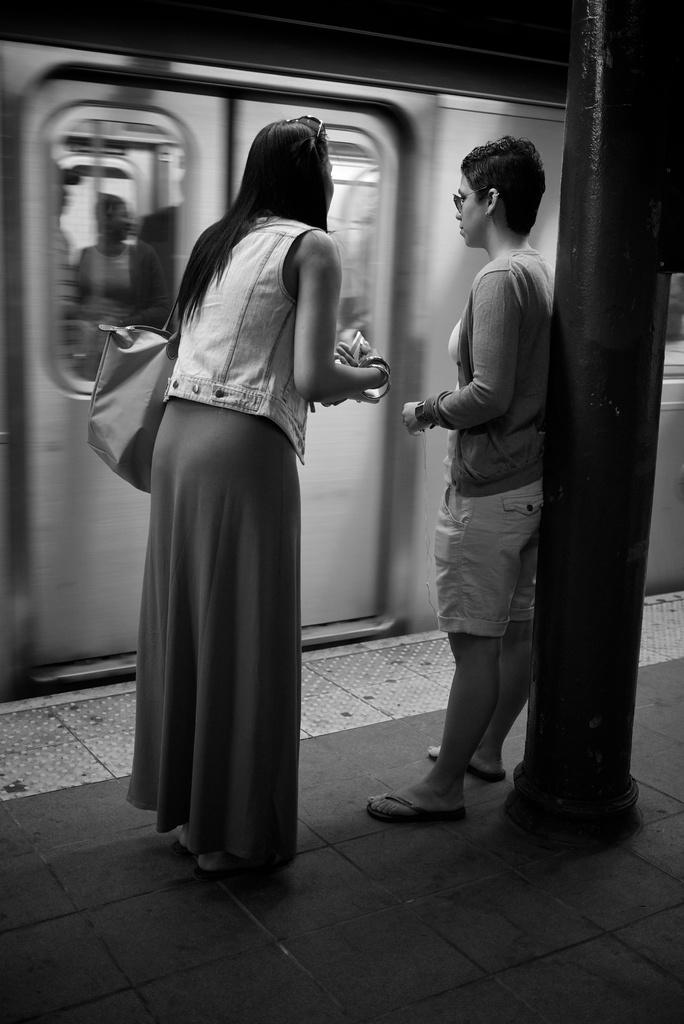Who is present in the image? There is a woman and a person in the image. What are the woman and the person doing? Both the woman and the person are standing on the ground. What else can be seen in the image? There is a train, a pole, and doors in the image. What is the color scheme of the image? The image is black and white in color. What type of noise can be heard coming from the drum in the image? There is no drum present in the image, so it is not possible to determine what noise might be heard. 